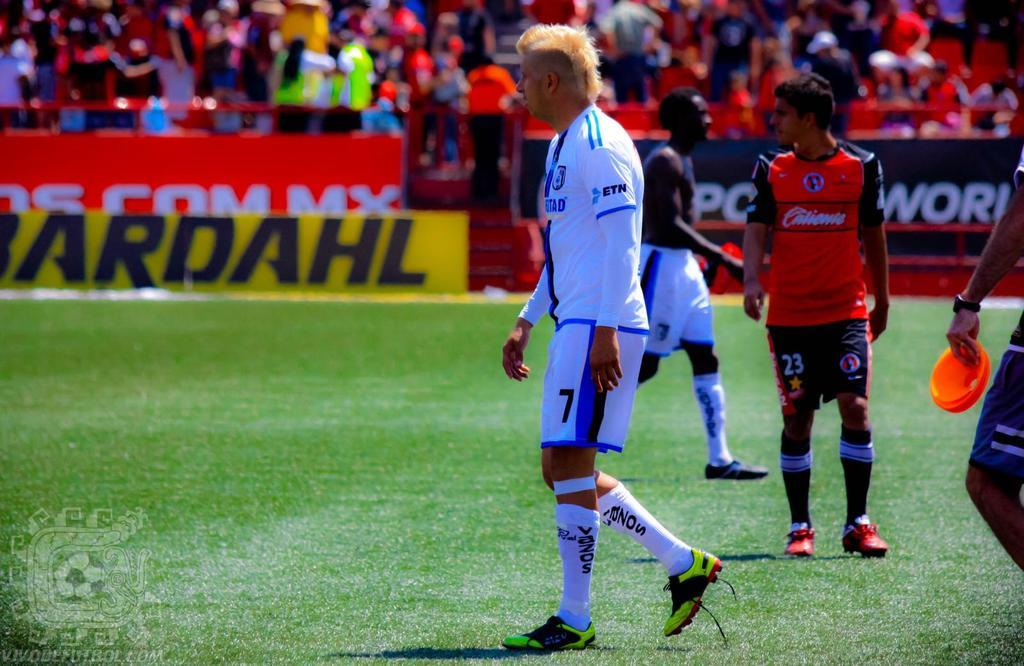<image>
Write a terse but informative summary of the picture. Male soccer player with white jersey that has ETN on the left sleeve. 